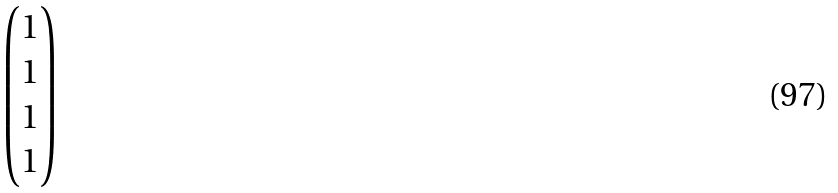Convert formula to latex. <formula><loc_0><loc_0><loc_500><loc_500>\begin{pmatrix} 1 \\ 1 \\ 1 \\ 1 \\ \end{pmatrix}</formula> 